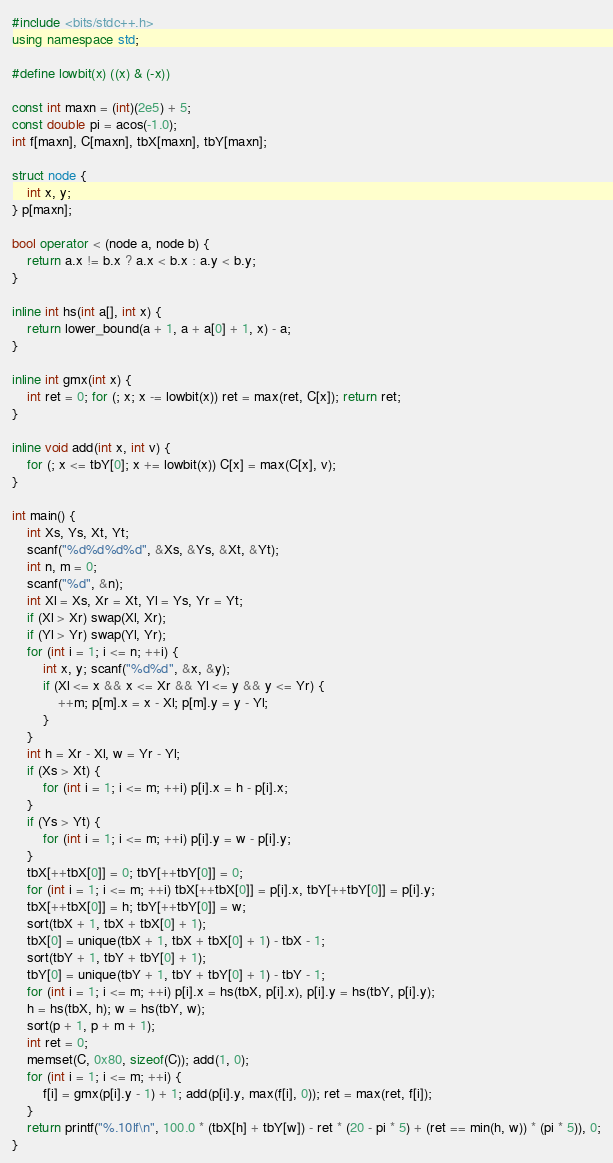Convert code to text. <code><loc_0><loc_0><loc_500><loc_500><_C++_>#include <bits/stdc++.h>
using namespace std;

#define lowbit(x) ((x) & (-x))

const int maxn = (int)(2e5) + 5;
const double pi = acos(-1.0);
int f[maxn], C[maxn], tbX[maxn], tbY[maxn];

struct node {
	int x, y;
} p[maxn];

bool operator < (node a, node b) {
	return a.x != b.x ? a.x < b.x : a.y < b.y;
}

inline int hs(int a[], int x) {
	return lower_bound(a + 1, a + a[0] + 1, x) - a;
}

inline int gmx(int x) {
	int ret = 0; for (; x; x -= lowbit(x)) ret = max(ret, C[x]); return ret;
}

inline void add(int x, int v) {
	for (; x <= tbY[0]; x += lowbit(x)) C[x] = max(C[x], v);  
}

int main() {
	int Xs, Ys, Xt, Yt;
	scanf("%d%d%d%d", &Xs, &Ys, &Xt, &Yt);
	int n, m = 0;
	scanf("%d", &n);
	int Xl = Xs, Xr = Xt, Yl = Ys, Yr = Yt;
	if (Xl > Xr) swap(Xl, Xr);
	if (Yl > Yr) swap(Yl, Yr);
	for (int i = 1; i <= n; ++i) {
		int x, y; scanf("%d%d", &x, &y);
		if (Xl <= x && x <= Xr && Yl <= y && y <= Yr) {
			++m; p[m].x = x - Xl; p[m].y = y - Yl;
		}
	}
	int h = Xr - Xl, w = Yr - Yl;
	if (Xs > Xt) {
		for (int i = 1; i <= m; ++i) p[i].x = h - p[i].x;
	}
	if (Ys > Yt) {
		for (int i = 1; i <= m; ++i) p[i].y = w - p[i].y;
	}
	tbX[++tbX[0]] = 0; tbY[++tbY[0]] = 0;
	for (int i = 1; i <= m; ++i) tbX[++tbX[0]] = p[i].x, tbY[++tbY[0]] = p[i].y;
	tbX[++tbX[0]] = h; tbY[++tbY[0]] = w;
	sort(tbX + 1, tbX + tbX[0] + 1);
	tbX[0] = unique(tbX + 1, tbX + tbX[0] + 1) - tbX - 1;
	sort(tbY + 1, tbY + tbY[0] + 1);
	tbY[0] = unique(tbY + 1, tbY + tbY[0] + 1) - tbY - 1;
	for (int i = 1; i <= m; ++i) p[i].x = hs(tbX, p[i].x), p[i].y = hs(tbY, p[i].y);
	h = hs(tbX, h); w = hs(tbY, w);
	sort(p + 1, p + m + 1);
	int ret = 0;
	memset(C, 0x80, sizeof(C)); add(1, 0);
	for (int i = 1; i <= m; ++i) {
		f[i] = gmx(p[i].y - 1) + 1; add(p[i].y, max(f[i], 0)); ret = max(ret, f[i]); 
	} 
	return printf("%.10lf\n", 100.0 * (tbX[h] + tbY[w]) - ret * (20 - pi * 5) + (ret == min(h, w)) * (pi * 5)), 0;
}</code> 